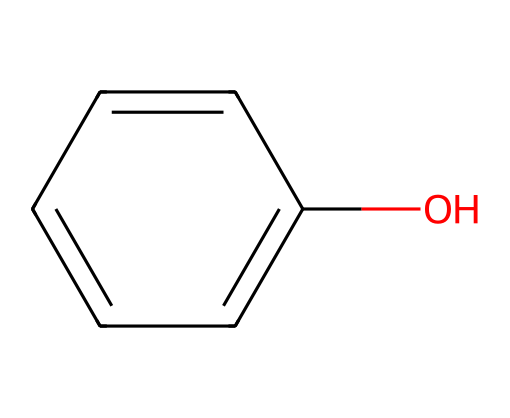What is the total number of carbon atoms in the structure? The structure c1(O)ccccc1 indicates a hexagonal ring where each vertex represents a carbon atom. There are six carbon atoms in total, one at each corner of the hexagon.
Answer: six How many hydrogen atoms are bonded to the carbon atoms in phenol? In phenol, c1(O)ccccc1, there are six carbon atoms, but one carbon is connected to a hydroxyl group (O) instead of a hydrogen atom. This leaves five hydrogen atoms bonded to the carbon atoms. Thus, there are five hydrogen atoms in total.
Answer: five What type of functional group is present in phenol? The hydroxyl group (O) bonded to one of the carbon atoms indicates that this compound contains an alcohol functional group. The placement of the hydroxyl (-OH) directly attached to the aromatic ring identifies phenol specifically.
Answer: hydroxyl What is the symmetry operation present in phenol’s hexagonal ring? The hexagonal structure exhibits rotational symmetry, specifically a 60-degree rotation around the center of the ring. This operation maintains the indistinguishable positions of the carbon atoms in the ring structure after rotation.
Answer: rotational symmetry How does the hydroxyl group influence phenol's reactivity? The hydroxyl group (-OH) provides phenol with acidic properties, as it can donate a proton (H+) to a solution, making it more reactive compared to benzene. This proton donation increases the electrophilic character of the aromatic ring, enhancing its reactivity in substitution reactions.
Answer: increases reactivity How many planes of symmetry are there in the structure of phenol? The hexagonal structure of phenol possesses three planes of symmetry, which can be visualized by slicing the molecule through its vertices and its center, dividing the structure into symmetrical halves.
Answer: three What is the molecular formula for phenol based on its structure? The structure c1(O)ccccc1 has a total of six carbon atoms and six hydrogen atoms minus one from the hydroxyl group, along with one oxygen atom. Thus, the molecular formula is C6H6O.
Answer: C6H6O 